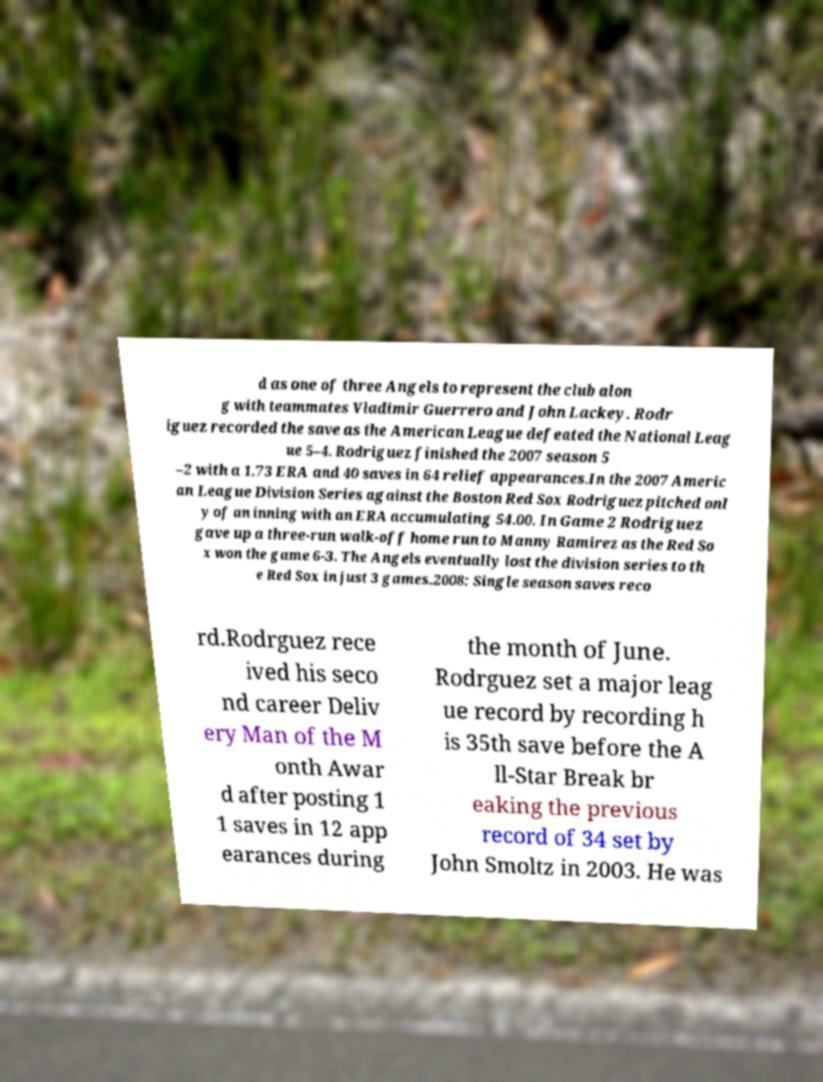Could you extract and type out the text from this image? d as one of three Angels to represent the club alon g with teammates Vladimir Guerrero and John Lackey. Rodr iguez recorded the save as the American League defeated the National Leag ue 5–4. Rodriguez finished the 2007 season 5 –2 with a 1.73 ERA and 40 saves in 64 relief appearances.In the 2007 Americ an League Division Series against the Boston Red Sox Rodriguez pitched onl y of an inning with an ERA accumulating 54.00. In Game 2 Rodriguez gave up a three-run walk-off home run to Manny Ramirez as the Red So x won the game 6-3. The Angels eventually lost the division series to th e Red Sox in just 3 games.2008: Single season saves reco rd.Rodrguez rece ived his seco nd career Deliv ery Man of the M onth Awar d after posting 1 1 saves in 12 app earances during the month of June. Rodrguez set a major leag ue record by recording h is 35th save before the A ll-Star Break br eaking the previous record of 34 set by John Smoltz in 2003. He was 